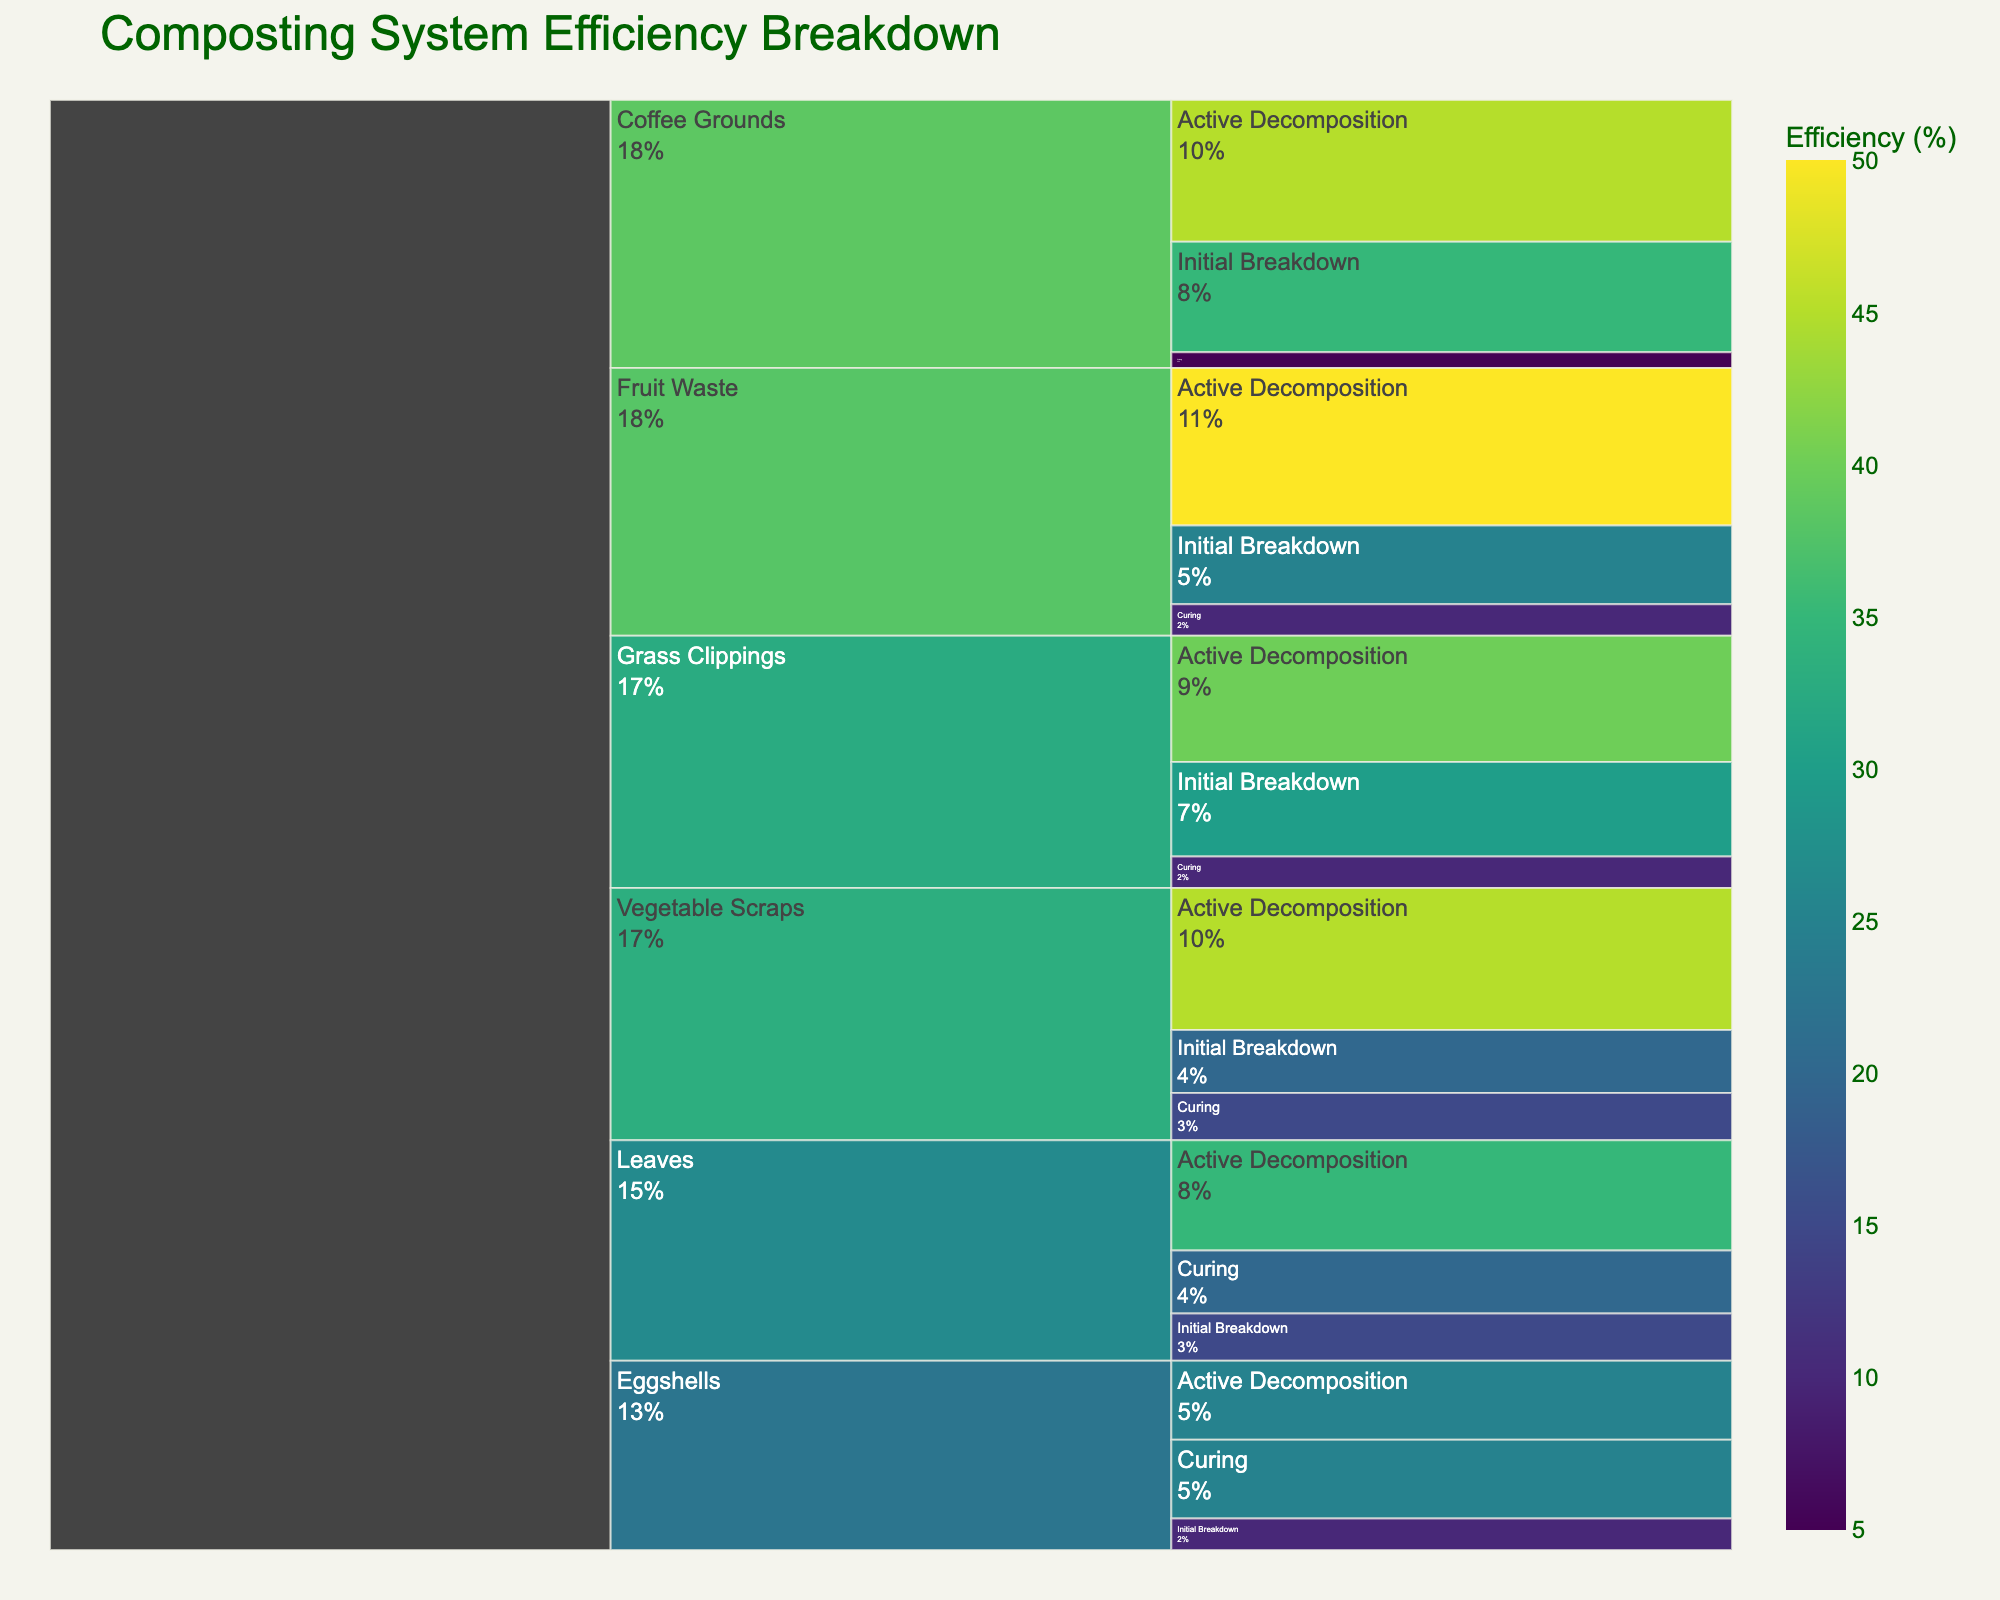What is the title of the icicle chart? The title is typically displayed at the top of the icicle chart, summarizing its content.
Answer: Composting System Efficiency Breakdown Which input material has the highest efficiency during the Initial Breakdown stage? Look at the efficiency values for each input material during the Initial Breakdown stage to find the highest value.
Answer: Coffee Grounds What is the efficiency of Eggshells during the Active Decomposition stage? Locate the decomposition stage for Eggshells and identify the efficiency percentage listed.
Answer: 25% Which decomposition stage for Vegetable Scraps has the lowest efficiency percentage? Review the stages for Vegetable Scraps and compare their efficiency percentages to find the lowest one.
Answer: Curing What's the total efficiency percentage for Grass Clippings across all decomposition stages? Add the efficiency percentages for Grass Clippings from all stages: Initial Breakdown (30), Active Decomposition (40), Curing (10). 30 + 40 + 10 = 80
Answer: 80% How does the Active Decomposition efficiency of Coffee Grounds compare to that of Leaves? Compare the efficiency percentages listed for Coffee Grounds and Leaves during the Active Decomposition stage.
Answer: Coffee Grounds are higher What is the difference in curing stage efficiency between Leaves and Coffee Grounds? Subtract the efficiency percentage of Coffee Grounds (5) from that of Leaves (20). 20 - 5 = 15
Answer: 15% Which material contributes the smallest efficiency in the Initial Breakdown stage? Identify and compare the efficiency percentages of each material in the Initial Breakdown stage.
Answer: Eggshells How does the total efficiency for Vegetable Scraps compare to Fruit Waste across all stages? Calculate the sum of efficiencies for both input materials across all stages: Vegetable Scraps (20 + 45 + 15 = 80), Fruit Waste (25 + 50 + 10 = 85). Then compare the totals.
Answer: Fruit Waste is higher What percentage of total efficiency of Grass Clippings is contributed by the Active Decomposition stage? Divide the Active Decomposition efficiency by the total efficiency for Grass Clippings and multiply by 100. (40/80) * 100 = 50
Answer: 50% 